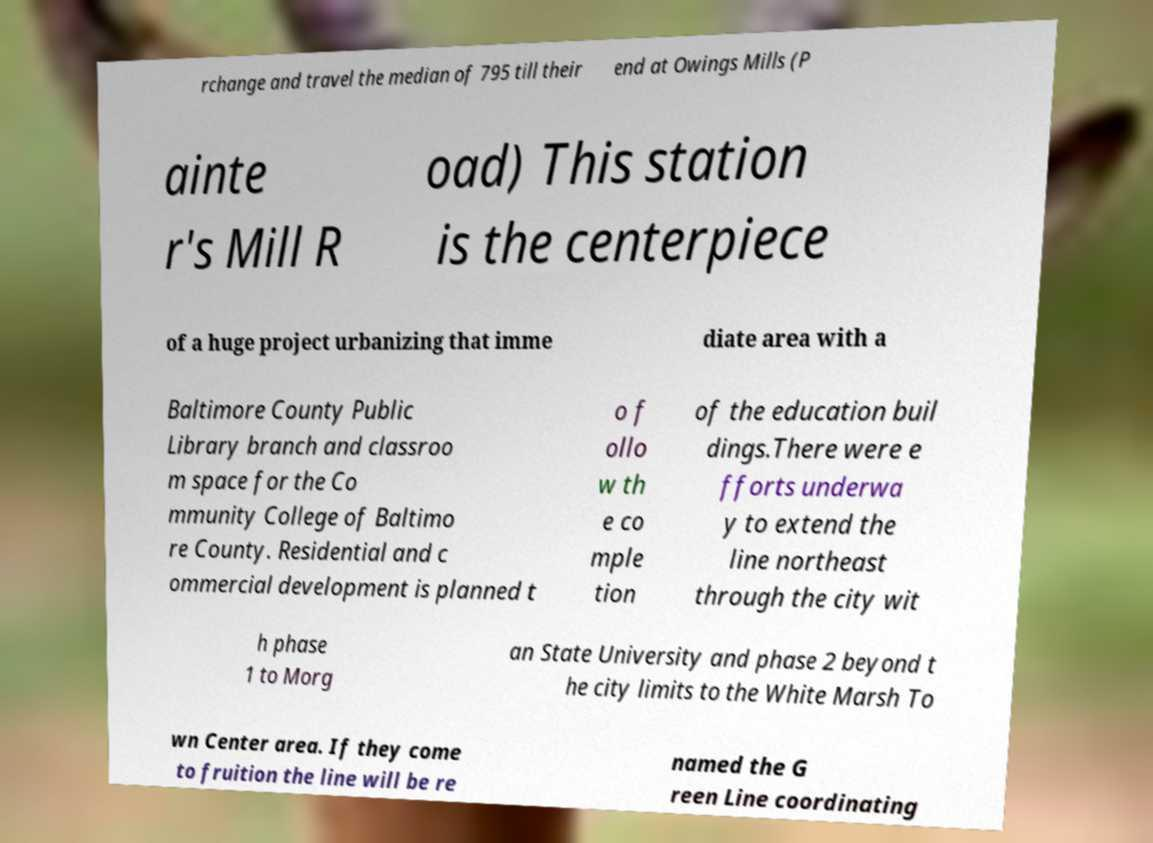Could you assist in decoding the text presented in this image and type it out clearly? rchange and travel the median of 795 till their end at Owings Mills (P ainte r's Mill R oad) This station is the centerpiece of a huge project urbanizing that imme diate area with a Baltimore County Public Library branch and classroo m space for the Co mmunity College of Baltimo re County. Residential and c ommercial development is planned t o f ollo w th e co mple tion of the education buil dings.There were e fforts underwa y to extend the line northeast through the city wit h phase 1 to Morg an State University and phase 2 beyond t he city limits to the White Marsh To wn Center area. If they come to fruition the line will be re named the G reen Line coordinating 